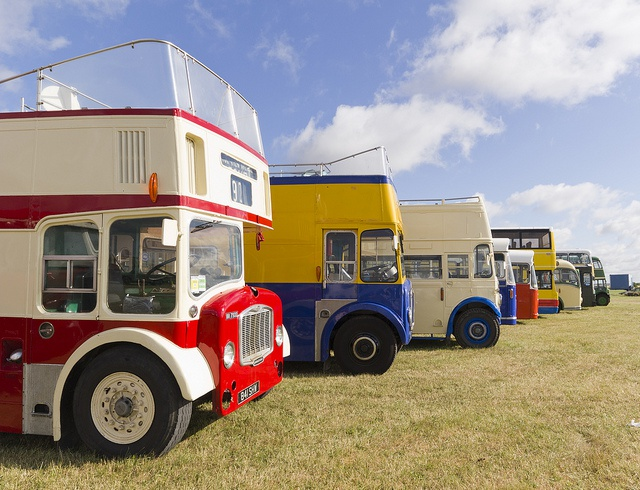Describe the objects in this image and their specific colors. I can see bus in lavender, darkgray, black, white, and maroon tones, bus in lavender, black, olive, and navy tones, bus in lavender, tan, black, and gray tones, bus in lavender, black, olive, gray, and darkgray tones, and bus in lavender, maroon, gray, and lightgray tones in this image. 